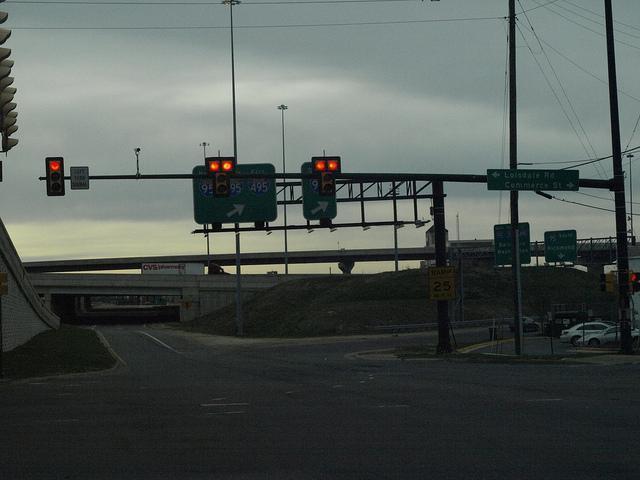How many red lights are there?
Give a very brief answer. 5. 